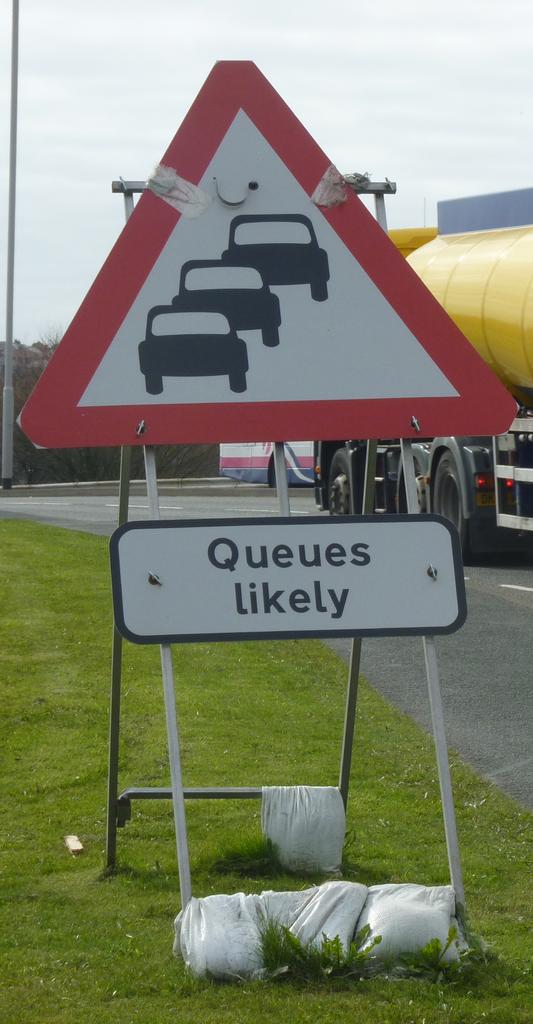Will there be a lot of queues?
Ensure brevity in your answer.  Likely. What are likely?
Provide a short and direct response. Queues. 